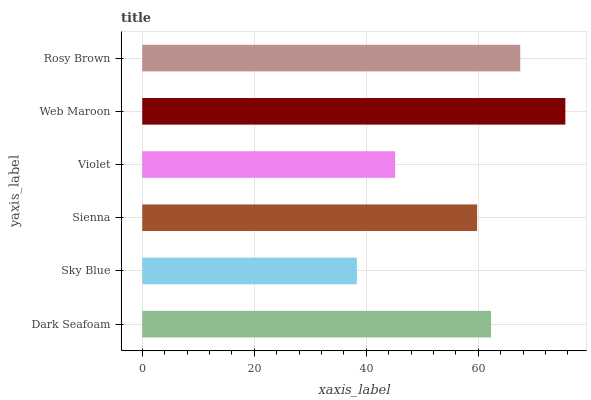Is Sky Blue the minimum?
Answer yes or no. Yes. Is Web Maroon the maximum?
Answer yes or no. Yes. Is Sienna the minimum?
Answer yes or no. No. Is Sienna the maximum?
Answer yes or no. No. Is Sienna greater than Sky Blue?
Answer yes or no. Yes. Is Sky Blue less than Sienna?
Answer yes or no. Yes. Is Sky Blue greater than Sienna?
Answer yes or no. No. Is Sienna less than Sky Blue?
Answer yes or no. No. Is Dark Seafoam the high median?
Answer yes or no. Yes. Is Sienna the low median?
Answer yes or no. Yes. Is Sky Blue the high median?
Answer yes or no. No. Is Web Maroon the low median?
Answer yes or no. No. 